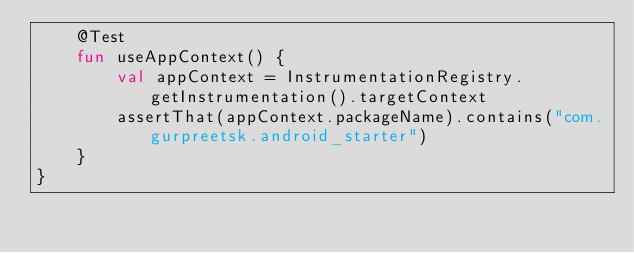<code> <loc_0><loc_0><loc_500><loc_500><_Kotlin_>    @Test
    fun useAppContext() {
        val appContext = InstrumentationRegistry.getInstrumentation().targetContext
        assertThat(appContext.packageName).contains("com.gurpreetsk.android_starter")
    }
}
</code> 